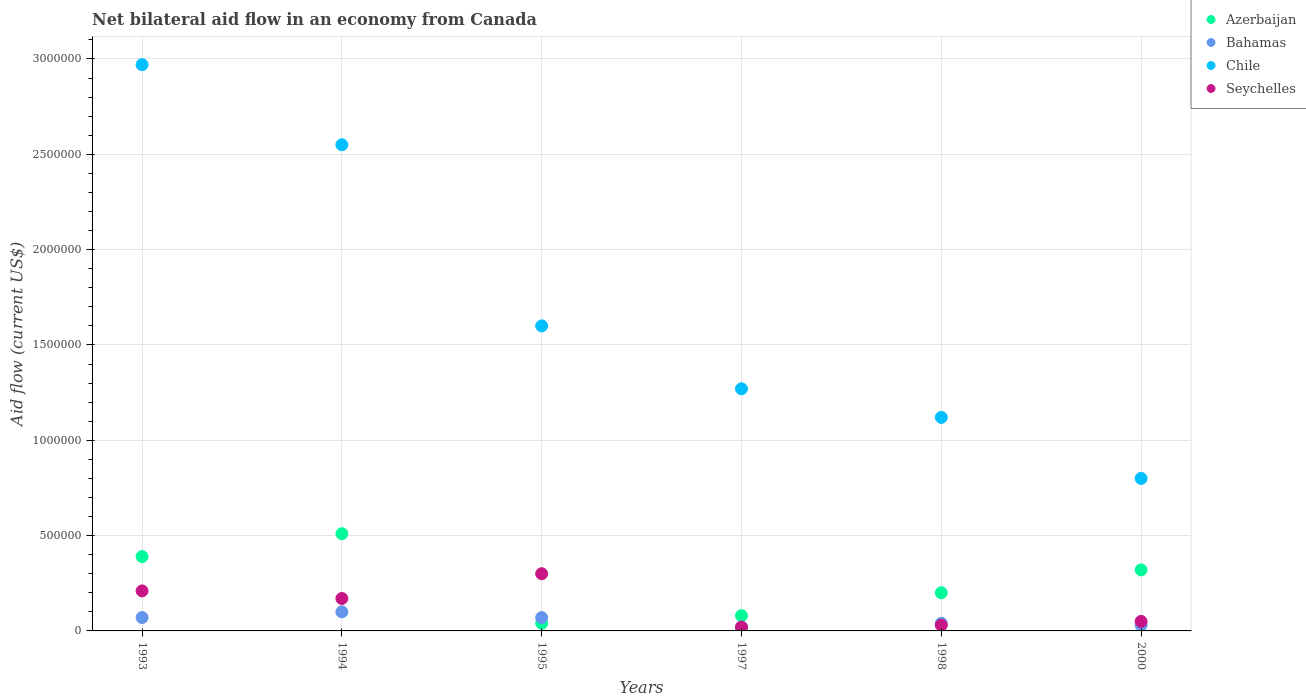How many different coloured dotlines are there?
Ensure brevity in your answer.  4. Is the number of dotlines equal to the number of legend labels?
Make the answer very short. Yes. What is the net bilateral aid flow in Azerbaijan in 1994?
Ensure brevity in your answer.  5.10e+05. Across all years, what is the maximum net bilateral aid flow in Seychelles?
Your answer should be compact. 3.00e+05. Across all years, what is the minimum net bilateral aid flow in Chile?
Your answer should be very brief. 8.00e+05. In which year was the net bilateral aid flow in Azerbaijan maximum?
Keep it short and to the point. 1994. In which year was the net bilateral aid flow in Chile minimum?
Provide a succinct answer. 2000. What is the total net bilateral aid flow in Chile in the graph?
Make the answer very short. 1.03e+07. What is the average net bilateral aid flow in Seychelles per year?
Ensure brevity in your answer.  1.30e+05. What is the ratio of the net bilateral aid flow in Azerbaijan in 1994 to that in 1997?
Provide a succinct answer. 6.38. In how many years, is the net bilateral aid flow in Seychelles greater than the average net bilateral aid flow in Seychelles taken over all years?
Give a very brief answer. 3. Is the sum of the net bilateral aid flow in Azerbaijan in 1997 and 2000 greater than the maximum net bilateral aid flow in Bahamas across all years?
Ensure brevity in your answer.  Yes. Is it the case that in every year, the sum of the net bilateral aid flow in Azerbaijan and net bilateral aid flow in Chile  is greater than the net bilateral aid flow in Bahamas?
Offer a very short reply. Yes. Does the net bilateral aid flow in Seychelles monotonically increase over the years?
Your answer should be very brief. No. Is the net bilateral aid flow in Chile strictly greater than the net bilateral aid flow in Seychelles over the years?
Your response must be concise. Yes. How many dotlines are there?
Provide a short and direct response. 4. Does the graph contain grids?
Offer a very short reply. Yes. Where does the legend appear in the graph?
Your response must be concise. Top right. What is the title of the graph?
Your answer should be very brief. Net bilateral aid flow in an economy from Canada. Does "Angola" appear as one of the legend labels in the graph?
Ensure brevity in your answer.  No. What is the label or title of the X-axis?
Your answer should be very brief. Years. What is the Aid flow (current US$) of Chile in 1993?
Provide a short and direct response. 2.97e+06. What is the Aid flow (current US$) in Seychelles in 1993?
Provide a short and direct response. 2.10e+05. What is the Aid flow (current US$) of Azerbaijan in 1994?
Give a very brief answer. 5.10e+05. What is the Aid flow (current US$) of Bahamas in 1994?
Provide a succinct answer. 1.00e+05. What is the Aid flow (current US$) in Chile in 1994?
Ensure brevity in your answer.  2.55e+06. What is the Aid flow (current US$) of Chile in 1995?
Provide a short and direct response. 1.60e+06. What is the Aid flow (current US$) of Chile in 1997?
Your answer should be compact. 1.27e+06. What is the Aid flow (current US$) in Chile in 1998?
Make the answer very short. 1.12e+06. What is the Aid flow (current US$) of Bahamas in 2000?
Your response must be concise. 3.00e+04. What is the Aid flow (current US$) of Chile in 2000?
Keep it short and to the point. 8.00e+05. What is the Aid flow (current US$) in Seychelles in 2000?
Provide a succinct answer. 5.00e+04. Across all years, what is the maximum Aid flow (current US$) in Azerbaijan?
Your answer should be compact. 5.10e+05. Across all years, what is the maximum Aid flow (current US$) of Bahamas?
Your answer should be compact. 1.00e+05. Across all years, what is the maximum Aid flow (current US$) of Chile?
Offer a terse response. 2.97e+06. Across all years, what is the minimum Aid flow (current US$) of Azerbaijan?
Your response must be concise. 4.00e+04. Across all years, what is the minimum Aid flow (current US$) in Bahamas?
Your answer should be very brief. 2.00e+04. Across all years, what is the minimum Aid flow (current US$) of Chile?
Provide a short and direct response. 8.00e+05. What is the total Aid flow (current US$) of Azerbaijan in the graph?
Provide a short and direct response. 1.54e+06. What is the total Aid flow (current US$) in Chile in the graph?
Offer a very short reply. 1.03e+07. What is the total Aid flow (current US$) in Seychelles in the graph?
Provide a succinct answer. 7.80e+05. What is the difference between the Aid flow (current US$) in Azerbaijan in 1993 and that in 1994?
Your response must be concise. -1.20e+05. What is the difference between the Aid flow (current US$) in Chile in 1993 and that in 1994?
Your answer should be very brief. 4.20e+05. What is the difference between the Aid flow (current US$) in Seychelles in 1993 and that in 1994?
Provide a succinct answer. 4.00e+04. What is the difference between the Aid flow (current US$) of Azerbaijan in 1993 and that in 1995?
Provide a short and direct response. 3.50e+05. What is the difference between the Aid flow (current US$) of Bahamas in 1993 and that in 1995?
Offer a terse response. 0. What is the difference between the Aid flow (current US$) in Chile in 1993 and that in 1995?
Offer a terse response. 1.37e+06. What is the difference between the Aid flow (current US$) of Azerbaijan in 1993 and that in 1997?
Your answer should be compact. 3.10e+05. What is the difference between the Aid flow (current US$) of Bahamas in 1993 and that in 1997?
Offer a very short reply. 5.00e+04. What is the difference between the Aid flow (current US$) in Chile in 1993 and that in 1997?
Provide a short and direct response. 1.70e+06. What is the difference between the Aid flow (current US$) in Seychelles in 1993 and that in 1997?
Your answer should be compact. 1.90e+05. What is the difference between the Aid flow (current US$) in Chile in 1993 and that in 1998?
Make the answer very short. 1.85e+06. What is the difference between the Aid flow (current US$) of Chile in 1993 and that in 2000?
Your answer should be compact. 2.17e+06. What is the difference between the Aid flow (current US$) of Bahamas in 1994 and that in 1995?
Make the answer very short. 3.00e+04. What is the difference between the Aid flow (current US$) in Chile in 1994 and that in 1995?
Your answer should be very brief. 9.50e+05. What is the difference between the Aid flow (current US$) in Seychelles in 1994 and that in 1995?
Keep it short and to the point. -1.30e+05. What is the difference between the Aid flow (current US$) in Azerbaijan in 1994 and that in 1997?
Make the answer very short. 4.30e+05. What is the difference between the Aid flow (current US$) of Bahamas in 1994 and that in 1997?
Offer a terse response. 8.00e+04. What is the difference between the Aid flow (current US$) of Chile in 1994 and that in 1997?
Your response must be concise. 1.28e+06. What is the difference between the Aid flow (current US$) of Seychelles in 1994 and that in 1997?
Provide a short and direct response. 1.50e+05. What is the difference between the Aid flow (current US$) of Chile in 1994 and that in 1998?
Your response must be concise. 1.43e+06. What is the difference between the Aid flow (current US$) of Azerbaijan in 1994 and that in 2000?
Your response must be concise. 1.90e+05. What is the difference between the Aid flow (current US$) in Bahamas in 1994 and that in 2000?
Keep it short and to the point. 7.00e+04. What is the difference between the Aid flow (current US$) of Chile in 1994 and that in 2000?
Provide a succinct answer. 1.75e+06. What is the difference between the Aid flow (current US$) in Azerbaijan in 1995 and that in 1997?
Ensure brevity in your answer.  -4.00e+04. What is the difference between the Aid flow (current US$) of Seychelles in 1995 and that in 1997?
Make the answer very short. 2.80e+05. What is the difference between the Aid flow (current US$) in Bahamas in 1995 and that in 1998?
Give a very brief answer. 3.00e+04. What is the difference between the Aid flow (current US$) in Chile in 1995 and that in 1998?
Your response must be concise. 4.80e+05. What is the difference between the Aid flow (current US$) in Azerbaijan in 1995 and that in 2000?
Provide a short and direct response. -2.80e+05. What is the difference between the Aid flow (current US$) of Chile in 1995 and that in 2000?
Keep it short and to the point. 8.00e+05. What is the difference between the Aid flow (current US$) in Bahamas in 1997 and that in 1998?
Make the answer very short. -2.00e+04. What is the difference between the Aid flow (current US$) of Chile in 1997 and that in 1998?
Offer a terse response. 1.50e+05. What is the difference between the Aid flow (current US$) in Azerbaijan in 1997 and that in 2000?
Your answer should be compact. -2.40e+05. What is the difference between the Aid flow (current US$) in Bahamas in 1997 and that in 2000?
Offer a terse response. -10000. What is the difference between the Aid flow (current US$) in Chile in 1997 and that in 2000?
Offer a terse response. 4.70e+05. What is the difference between the Aid flow (current US$) in Seychelles in 1997 and that in 2000?
Give a very brief answer. -3.00e+04. What is the difference between the Aid flow (current US$) of Azerbaijan in 1998 and that in 2000?
Make the answer very short. -1.20e+05. What is the difference between the Aid flow (current US$) of Bahamas in 1998 and that in 2000?
Ensure brevity in your answer.  10000. What is the difference between the Aid flow (current US$) of Chile in 1998 and that in 2000?
Provide a short and direct response. 3.20e+05. What is the difference between the Aid flow (current US$) in Azerbaijan in 1993 and the Aid flow (current US$) in Bahamas in 1994?
Make the answer very short. 2.90e+05. What is the difference between the Aid flow (current US$) of Azerbaijan in 1993 and the Aid flow (current US$) of Chile in 1994?
Make the answer very short. -2.16e+06. What is the difference between the Aid flow (current US$) of Bahamas in 1993 and the Aid flow (current US$) of Chile in 1994?
Your answer should be very brief. -2.48e+06. What is the difference between the Aid flow (current US$) of Bahamas in 1993 and the Aid flow (current US$) of Seychelles in 1994?
Offer a terse response. -1.00e+05. What is the difference between the Aid flow (current US$) in Chile in 1993 and the Aid flow (current US$) in Seychelles in 1994?
Make the answer very short. 2.80e+06. What is the difference between the Aid flow (current US$) of Azerbaijan in 1993 and the Aid flow (current US$) of Bahamas in 1995?
Your answer should be very brief. 3.20e+05. What is the difference between the Aid flow (current US$) in Azerbaijan in 1993 and the Aid flow (current US$) in Chile in 1995?
Your answer should be very brief. -1.21e+06. What is the difference between the Aid flow (current US$) in Azerbaijan in 1993 and the Aid flow (current US$) in Seychelles in 1995?
Your answer should be compact. 9.00e+04. What is the difference between the Aid flow (current US$) in Bahamas in 1993 and the Aid flow (current US$) in Chile in 1995?
Ensure brevity in your answer.  -1.53e+06. What is the difference between the Aid flow (current US$) in Chile in 1993 and the Aid flow (current US$) in Seychelles in 1995?
Your answer should be compact. 2.67e+06. What is the difference between the Aid flow (current US$) in Azerbaijan in 1993 and the Aid flow (current US$) in Bahamas in 1997?
Provide a short and direct response. 3.70e+05. What is the difference between the Aid flow (current US$) of Azerbaijan in 1993 and the Aid flow (current US$) of Chile in 1997?
Offer a terse response. -8.80e+05. What is the difference between the Aid flow (current US$) of Azerbaijan in 1993 and the Aid flow (current US$) of Seychelles in 1997?
Ensure brevity in your answer.  3.70e+05. What is the difference between the Aid flow (current US$) in Bahamas in 1993 and the Aid flow (current US$) in Chile in 1997?
Keep it short and to the point. -1.20e+06. What is the difference between the Aid flow (current US$) in Chile in 1993 and the Aid flow (current US$) in Seychelles in 1997?
Offer a very short reply. 2.95e+06. What is the difference between the Aid flow (current US$) in Azerbaijan in 1993 and the Aid flow (current US$) in Bahamas in 1998?
Keep it short and to the point. 3.50e+05. What is the difference between the Aid flow (current US$) in Azerbaijan in 1993 and the Aid flow (current US$) in Chile in 1998?
Your answer should be compact. -7.30e+05. What is the difference between the Aid flow (current US$) of Azerbaijan in 1993 and the Aid flow (current US$) of Seychelles in 1998?
Give a very brief answer. 3.60e+05. What is the difference between the Aid flow (current US$) in Bahamas in 1993 and the Aid flow (current US$) in Chile in 1998?
Your answer should be very brief. -1.05e+06. What is the difference between the Aid flow (current US$) in Bahamas in 1993 and the Aid flow (current US$) in Seychelles in 1998?
Provide a succinct answer. 4.00e+04. What is the difference between the Aid flow (current US$) in Chile in 1993 and the Aid flow (current US$) in Seychelles in 1998?
Keep it short and to the point. 2.94e+06. What is the difference between the Aid flow (current US$) in Azerbaijan in 1993 and the Aid flow (current US$) in Chile in 2000?
Make the answer very short. -4.10e+05. What is the difference between the Aid flow (current US$) of Bahamas in 1993 and the Aid flow (current US$) of Chile in 2000?
Provide a short and direct response. -7.30e+05. What is the difference between the Aid flow (current US$) in Bahamas in 1993 and the Aid flow (current US$) in Seychelles in 2000?
Provide a short and direct response. 2.00e+04. What is the difference between the Aid flow (current US$) of Chile in 1993 and the Aid flow (current US$) of Seychelles in 2000?
Your answer should be very brief. 2.92e+06. What is the difference between the Aid flow (current US$) in Azerbaijan in 1994 and the Aid flow (current US$) in Chile in 1995?
Offer a terse response. -1.09e+06. What is the difference between the Aid flow (current US$) of Azerbaijan in 1994 and the Aid flow (current US$) of Seychelles in 1995?
Ensure brevity in your answer.  2.10e+05. What is the difference between the Aid flow (current US$) of Bahamas in 1994 and the Aid flow (current US$) of Chile in 1995?
Offer a terse response. -1.50e+06. What is the difference between the Aid flow (current US$) in Chile in 1994 and the Aid flow (current US$) in Seychelles in 1995?
Provide a short and direct response. 2.25e+06. What is the difference between the Aid flow (current US$) of Azerbaijan in 1994 and the Aid flow (current US$) of Bahamas in 1997?
Provide a succinct answer. 4.90e+05. What is the difference between the Aid flow (current US$) in Azerbaijan in 1994 and the Aid flow (current US$) in Chile in 1997?
Your response must be concise. -7.60e+05. What is the difference between the Aid flow (current US$) in Bahamas in 1994 and the Aid flow (current US$) in Chile in 1997?
Keep it short and to the point. -1.17e+06. What is the difference between the Aid flow (current US$) of Bahamas in 1994 and the Aid flow (current US$) of Seychelles in 1997?
Your answer should be compact. 8.00e+04. What is the difference between the Aid flow (current US$) of Chile in 1994 and the Aid flow (current US$) of Seychelles in 1997?
Provide a succinct answer. 2.53e+06. What is the difference between the Aid flow (current US$) in Azerbaijan in 1994 and the Aid flow (current US$) in Bahamas in 1998?
Provide a succinct answer. 4.70e+05. What is the difference between the Aid flow (current US$) of Azerbaijan in 1994 and the Aid flow (current US$) of Chile in 1998?
Offer a terse response. -6.10e+05. What is the difference between the Aid flow (current US$) of Azerbaijan in 1994 and the Aid flow (current US$) of Seychelles in 1998?
Offer a terse response. 4.80e+05. What is the difference between the Aid flow (current US$) in Bahamas in 1994 and the Aid flow (current US$) in Chile in 1998?
Offer a very short reply. -1.02e+06. What is the difference between the Aid flow (current US$) in Chile in 1994 and the Aid flow (current US$) in Seychelles in 1998?
Provide a succinct answer. 2.52e+06. What is the difference between the Aid flow (current US$) in Azerbaijan in 1994 and the Aid flow (current US$) in Bahamas in 2000?
Ensure brevity in your answer.  4.80e+05. What is the difference between the Aid flow (current US$) of Azerbaijan in 1994 and the Aid flow (current US$) of Seychelles in 2000?
Provide a succinct answer. 4.60e+05. What is the difference between the Aid flow (current US$) of Bahamas in 1994 and the Aid flow (current US$) of Chile in 2000?
Offer a very short reply. -7.00e+05. What is the difference between the Aid flow (current US$) of Chile in 1994 and the Aid flow (current US$) of Seychelles in 2000?
Provide a succinct answer. 2.50e+06. What is the difference between the Aid flow (current US$) in Azerbaijan in 1995 and the Aid flow (current US$) in Chile in 1997?
Your answer should be very brief. -1.23e+06. What is the difference between the Aid flow (current US$) in Azerbaijan in 1995 and the Aid flow (current US$) in Seychelles in 1997?
Provide a succinct answer. 2.00e+04. What is the difference between the Aid flow (current US$) in Bahamas in 1995 and the Aid flow (current US$) in Chile in 1997?
Give a very brief answer. -1.20e+06. What is the difference between the Aid flow (current US$) of Bahamas in 1995 and the Aid flow (current US$) of Seychelles in 1997?
Make the answer very short. 5.00e+04. What is the difference between the Aid flow (current US$) of Chile in 1995 and the Aid flow (current US$) of Seychelles in 1997?
Offer a terse response. 1.58e+06. What is the difference between the Aid flow (current US$) in Azerbaijan in 1995 and the Aid flow (current US$) in Chile in 1998?
Your answer should be compact. -1.08e+06. What is the difference between the Aid flow (current US$) in Bahamas in 1995 and the Aid flow (current US$) in Chile in 1998?
Give a very brief answer. -1.05e+06. What is the difference between the Aid flow (current US$) of Bahamas in 1995 and the Aid flow (current US$) of Seychelles in 1998?
Your answer should be very brief. 4.00e+04. What is the difference between the Aid flow (current US$) in Chile in 1995 and the Aid flow (current US$) in Seychelles in 1998?
Your answer should be compact. 1.57e+06. What is the difference between the Aid flow (current US$) of Azerbaijan in 1995 and the Aid flow (current US$) of Bahamas in 2000?
Offer a very short reply. 10000. What is the difference between the Aid flow (current US$) of Azerbaijan in 1995 and the Aid flow (current US$) of Chile in 2000?
Ensure brevity in your answer.  -7.60e+05. What is the difference between the Aid flow (current US$) of Bahamas in 1995 and the Aid flow (current US$) of Chile in 2000?
Your response must be concise. -7.30e+05. What is the difference between the Aid flow (current US$) of Bahamas in 1995 and the Aid flow (current US$) of Seychelles in 2000?
Ensure brevity in your answer.  2.00e+04. What is the difference between the Aid flow (current US$) of Chile in 1995 and the Aid flow (current US$) of Seychelles in 2000?
Your answer should be very brief. 1.55e+06. What is the difference between the Aid flow (current US$) of Azerbaijan in 1997 and the Aid flow (current US$) of Chile in 1998?
Offer a terse response. -1.04e+06. What is the difference between the Aid flow (current US$) in Bahamas in 1997 and the Aid flow (current US$) in Chile in 1998?
Provide a short and direct response. -1.10e+06. What is the difference between the Aid flow (current US$) of Bahamas in 1997 and the Aid flow (current US$) of Seychelles in 1998?
Your answer should be compact. -10000. What is the difference between the Aid flow (current US$) of Chile in 1997 and the Aid flow (current US$) of Seychelles in 1998?
Offer a very short reply. 1.24e+06. What is the difference between the Aid flow (current US$) in Azerbaijan in 1997 and the Aid flow (current US$) in Bahamas in 2000?
Your answer should be compact. 5.00e+04. What is the difference between the Aid flow (current US$) of Azerbaijan in 1997 and the Aid flow (current US$) of Chile in 2000?
Make the answer very short. -7.20e+05. What is the difference between the Aid flow (current US$) in Azerbaijan in 1997 and the Aid flow (current US$) in Seychelles in 2000?
Provide a succinct answer. 3.00e+04. What is the difference between the Aid flow (current US$) of Bahamas in 1997 and the Aid flow (current US$) of Chile in 2000?
Give a very brief answer. -7.80e+05. What is the difference between the Aid flow (current US$) in Chile in 1997 and the Aid flow (current US$) in Seychelles in 2000?
Make the answer very short. 1.22e+06. What is the difference between the Aid flow (current US$) in Azerbaijan in 1998 and the Aid flow (current US$) in Bahamas in 2000?
Offer a very short reply. 1.70e+05. What is the difference between the Aid flow (current US$) in Azerbaijan in 1998 and the Aid flow (current US$) in Chile in 2000?
Offer a terse response. -6.00e+05. What is the difference between the Aid flow (current US$) in Bahamas in 1998 and the Aid flow (current US$) in Chile in 2000?
Your answer should be compact. -7.60e+05. What is the difference between the Aid flow (current US$) in Chile in 1998 and the Aid flow (current US$) in Seychelles in 2000?
Offer a very short reply. 1.07e+06. What is the average Aid flow (current US$) in Azerbaijan per year?
Offer a very short reply. 2.57e+05. What is the average Aid flow (current US$) in Bahamas per year?
Offer a very short reply. 5.50e+04. What is the average Aid flow (current US$) of Chile per year?
Your response must be concise. 1.72e+06. What is the average Aid flow (current US$) of Seychelles per year?
Offer a terse response. 1.30e+05. In the year 1993, what is the difference between the Aid flow (current US$) of Azerbaijan and Aid flow (current US$) of Chile?
Offer a very short reply. -2.58e+06. In the year 1993, what is the difference between the Aid flow (current US$) in Bahamas and Aid flow (current US$) in Chile?
Provide a succinct answer. -2.90e+06. In the year 1993, what is the difference between the Aid flow (current US$) of Bahamas and Aid flow (current US$) of Seychelles?
Provide a short and direct response. -1.40e+05. In the year 1993, what is the difference between the Aid flow (current US$) of Chile and Aid flow (current US$) of Seychelles?
Offer a very short reply. 2.76e+06. In the year 1994, what is the difference between the Aid flow (current US$) in Azerbaijan and Aid flow (current US$) in Chile?
Your answer should be very brief. -2.04e+06. In the year 1994, what is the difference between the Aid flow (current US$) of Bahamas and Aid flow (current US$) of Chile?
Your answer should be very brief. -2.45e+06. In the year 1994, what is the difference between the Aid flow (current US$) of Chile and Aid flow (current US$) of Seychelles?
Make the answer very short. 2.38e+06. In the year 1995, what is the difference between the Aid flow (current US$) in Azerbaijan and Aid flow (current US$) in Bahamas?
Offer a very short reply. -3.00e+04. In the year 1995, what is the difference between the Aid flow (current US$) of Azerbaijan and Aid flow (current US$) of Chile?
Your answer should be compact. -1.56e+06. In the year 1995, what is the difference between the Aid flow (current US$) of Bahamas and Aid flow (current US$) of Chile?
Give a very brief answer. -1.53e+06. In the year 1995, what is the difference between the Aid flow (current US$) in Bahamas and Aid flow (current US$) in Seychelles?
Provide a succinct answer. -2.30e+05. In the year 1995, what is the difference between the Aid flow (current US$) of Chile and Aid flow (current US$) of Seychelles?
Provide a succinct answer. 1.30e+06. In the year 1997, what is the difference between the Aid flow (current US$) of Azerbaijan and Aid flow (current US$) of Chile?
Provide a succinct answer. -1.19e+06. In the year 1997, what is the difference between the Aid flow (current US$) of Bahamas and Aid flow (current US$) of Chile?
Offer a very short reply. -1.25e+06. In the year 1997, what is the difference between the Aid flow (current US$) in Chile and Aid flow (current US$) in Seychelles?
Your response must be concise. 1.25e+06. In the year 1998, what is the difference between the Aid flow (current US$) in Azerbaijan and Aid flow (current US$) in Bahamas?
Give a very brief answer. 1.60e+05. In the year 1998, what is the difference between the Aid flow (current US$) of Azerbaijan and Aid flow (current US$) of Chile?
Give a very brief answer. -9.20e+05. In the year 1998, what is the difference between the Aid flow (current US$) of Bahamas and Aid flow (current US$) of Chile?
Your answer should be very brief. -1.08e+06. In the year 1998, what is the difference between the Aid flow (current US$) of Chile and Aid flow (current US$) of Seychelles?
Offer a terse response. 1.09e+06. In the year 2000, what is the difference between the Aid flow (current US$) in Azerbaijan and Aid flow (current US$) in Bahamas?
Provide a short and direct response. 2.90e+05. In the year 2000, what is the difference between the Aid flow (current US$) in Azerbaijan and Aid flow (current US$) in Chile?
Give a very brief answer. -4.80e+05. In the year 2000, what is the difference between the Aid flow (current US$) in Azerbaijan and Aid flow (current US$) in Seychelles?
Give a very brief answer. 2.70e+05. In the year 2000, what is the difference between the Aid flow (current US$) in Bahamas and Aid flow (current US$) in Chile?
Offer a very short reply. -7.70e+05. In the year 2000, what is the difference between the Aid flow (current US$) in Bahamas and Aid flow (current US$) in Seychelles?
Provide a short and direct response. -2.00e+04. In the year 2000, what is the difference between the Aid flow (current US$) of Chile and Aid flow (current US$) of Seychelles?
Offer a very short reply. 7.50e+05. What is the ratio of the Aid flow (current US$) of Azerbaijan in 1993 to that in 1994?
Your answer should be very brief. 0.76. What is the ratio of the Aid flow (current US$) of Chile in 1993 to that in 1994?
Give a very brief answer. 1.16. What is the ratio of the Aid flow (current US$) of Seychelles in 1993 to that in 1994?
Your answer should be very brief. 1.24. What is the ratio of the Aid flow (current US$) in Azerbaijan in 1993 to that in 1995?
Your answer should be compact. 9.75. What is the ratio of the Aid flow (current US$) in Chile in 1993 to that in 1995?
Your answer should be very brief. 1.86. What is the ratio of the Aid flow (current US$) in Seychelles in 1993 to that in 1995?
Your answer should be compact. 0.7. What is the ratio of the Aid flow (current US$) in Azerbaijan in 1993 to that in 1997?
Your answer should be very brief. 4.88. What is the ratio of the Aid flow (current US$) of Chile in 1993 to that in 1997?
Offer a very short reply. 2.34. What is the ratio of the Aid flow (current US$) of Seychelles in 1993 to that in 1997?
Make the answer very short. 10.5. What is the ratio of the Aid flow (current US$) of Azerbaijan in 1993 to that in 1998?
Your answer should be compact. 1.95. What is the ratio of the Aid flow (current US$) of Chile in 1993 to that in 1998?
Ensure brevity in your answer.  2.65. What is the ratio of the Aid flow (current US$) in Seychelles in 1993 to that in 1998?
Offer a terse response. 7. What is the ratio of the Aid flow (current US$) in Azerbaijan in 1993 to that in 2000?
Offer a very short reply. 1.22. What is the ratio of the Aid flow (current US$) in Bahamas in 1993 to that in 2000?
Ensure brevity in your answer.  2.33. What is the ratio of the Aid flow (current US$) of Chile in 1993 to that in 2000?
Make the answer very short. 3.71. What is the ratio of the Aid flow (current US$) in Azerbaijan in 1994 to that in 1995?
Provide a succinct answer. 12.75. What is the ratio of the Aid flow (current US$) in Bahamas in 1994 to that in 1995?
Make the answer very short. 1.43. What is the ratio of the Aid flow (current US$) in Chile in 1994 to that in 1995?
Give a very brief answer. 1.59. What is the ratio of the Aid flow (current US$) of Seychelles in 1994 to that in 1995?
Give a very brief answer. 0.57. What is the ratio of the Aid flow (current US$) of Azerbaijan in 1994 to that in 1997?
Ensure brevity in your answer.  6.38. What is the ratio of the Aid flow (current US$) of Chile in 1994 to that in 1997?
Offer a very short reply. 2.01. What is the ratio of the Aid flow (current US$) in Azerbaijan in 1994 to that in 1998?
Give a very brief answer. 2.55. What is the ratio of the Aid flow (current US$) in Chile in 1994 to that in 1998?
Provide a short and direct response. 2.28. What is the ratio of the Aid flow (current US$) in Seychelles in 1994 to that in 1998?
Offer a very short reply. 5.67. What is the ratio of the Aid flow (current US$) of Azerbaijan in 1994 to that in 2000?
Your answer should be very brief. 1.59. What is the ratio of the Aid flow (current US$) of Bahamas in 1994 to that in 2000?
Provide a short and direct response. 3.33. What is the ratio of the Aid flow (current US$) in Chile in 1994 to that in 2000?
Give a very brief answer. 3.19. What is the ratio of the Aid flow (current US$) of Azerbaijan in 1995 to that in 1997?
Your response must be concise. 0.5. What is the ratio of the Aid flow (current US$) in Bahamas in 1995 to that in 1997?
Ensure brevity in your answer.  3.5. What is the ratio of the Aid flow (current US$) in Chile in 1995 to that in 1997?
Give a very brief answer. 1.26. What is the ratio of the Aid flow (current US$) of Seychelles in 1995 to that in 1997?
Provide a succinct answer. 15. What is the ratio of the Aid flow (current US$) in Chile in 1995 to that in 1998?
Keep it short and to the point. 1.43. What is the ratio of the Aid flow (current US$) of Seychelles in 1995 to that in 1998?
Your response must be concise. 10. What is the ratio of the Aid flow (current US$) of Azerbaijan in 1995 to that in 2000?
Your answer should be very brief. 0.12. What is the ratio of the Aid flow (current US$) of Bahamas in 1995 to that in 2000?
Your response must be concise. 2.33. What is the ratio of the Aid flow (current US$) in Chile in 1995 to that in 2000?
Provide a succinct answer. 2. What is the ratio of the Aid flow (current US$) in Seychelles in 1995 to that in 2000?
Your answer should be very brief. 6. What is the ratio of the Aid flow (current US$) of Azerbaijan in 1997 to that in 1998?
Offer a terse response. 0.4. What is the ratio of the Aid flow (current US$) of Chile in 1997 to that in 1998?
Make the answer very short. 1.13. What is the ratio of the Aid flow (current US$) in Seychelles in 1997 to that in 1998?
Provide a short and direct response. 0.67. What is the ratio of the Aid flow (current US$) in Chile in 1997 to that in 2000?
Offer a very short reply. 1.59. What is the ratio of the Aid flow (current US$) of Seychelles in 1997 to that in 2000?
Make the answer very short. 0.4. What is the ratio of the Aid flow (current US$) in Bahamas in 1998 to that in 2000?
Provide a short and direct response. 1.33. What is the ratio of the Aid flow (current US$) of Chile in 1998 to that in 2000?
Make the answer very short. 1.4. What is the ratio of the Aid flow (current US$) of Seychelles in 1998 to that in 2000?
Offer a terse response. 0.6. What is the difference between the highest and the second highest Aid flow (current US$) in Azerbaijan?
Offer a very short reply. 1.20e+05. What is the difference between the highest and the second highest Aid flow (current US$) of Seychelles?
Offer a terse response. 9.00e+04. What is the difference between the highest and the lowest Aid flow (current US$) in Azerbaijan?
Provide a short and direct response. 4.70e+05. What is the difference between the highest and the lowest Aid flow (current US$) of Bahamas?
Offer a very short reply. 8.00e+04. What is the difference between the highest and the lowest Aid flow (current US$) in Chile?
Offer a terse response. 2.17e+06. 